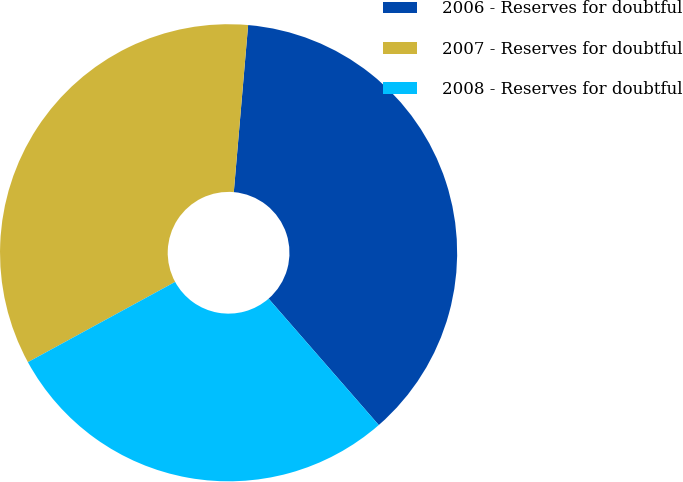Convert chart. <chart><loc_0><loc_0><loc_500><loc_500><pie_chart><fcel>2006 - Reserves for doubtful<fcel>2007 - Reserves for doubtful<fcel>2008 - Reserves for doubtful<nl><fcel>37.23%<fcel>34.31%<fcel>28.47%<nl></chart> 